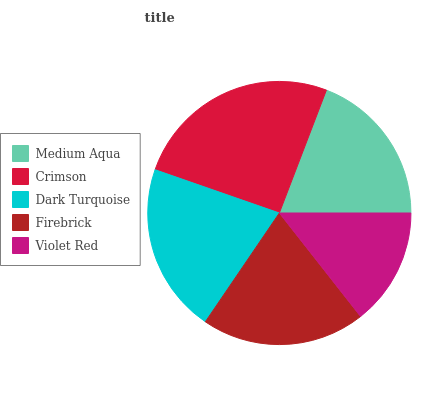Is Violet Red the minimum?
Answer yes or no. Yes. Is Crimson the maximum?
Answer yes or no. Yes. Is Dark Turquoise the minimum?
Answer yes or no. No. Is Dark Turquoise the maximum?
Answer yes or no. No. Is Crimson greater than Dark Turquoise?
Answer yes or no. Yes. Is Dark Turquoise less than Crimson?
Answer yes or no. Yes. Is Dark Turquoise greater than Crimson?
Answer yes or no. No. Is Crimson less than Dark Turquoise?
Answer yes or no. No. Is Firebrick the high median?
Answer yes or no. Yes. Is Firebrick the low median?
Answer yes or no. Yes. Is Violet Red the high median?
Answer yes or no. No. Is Violet Red the low median?
Answer yes or no. No. 